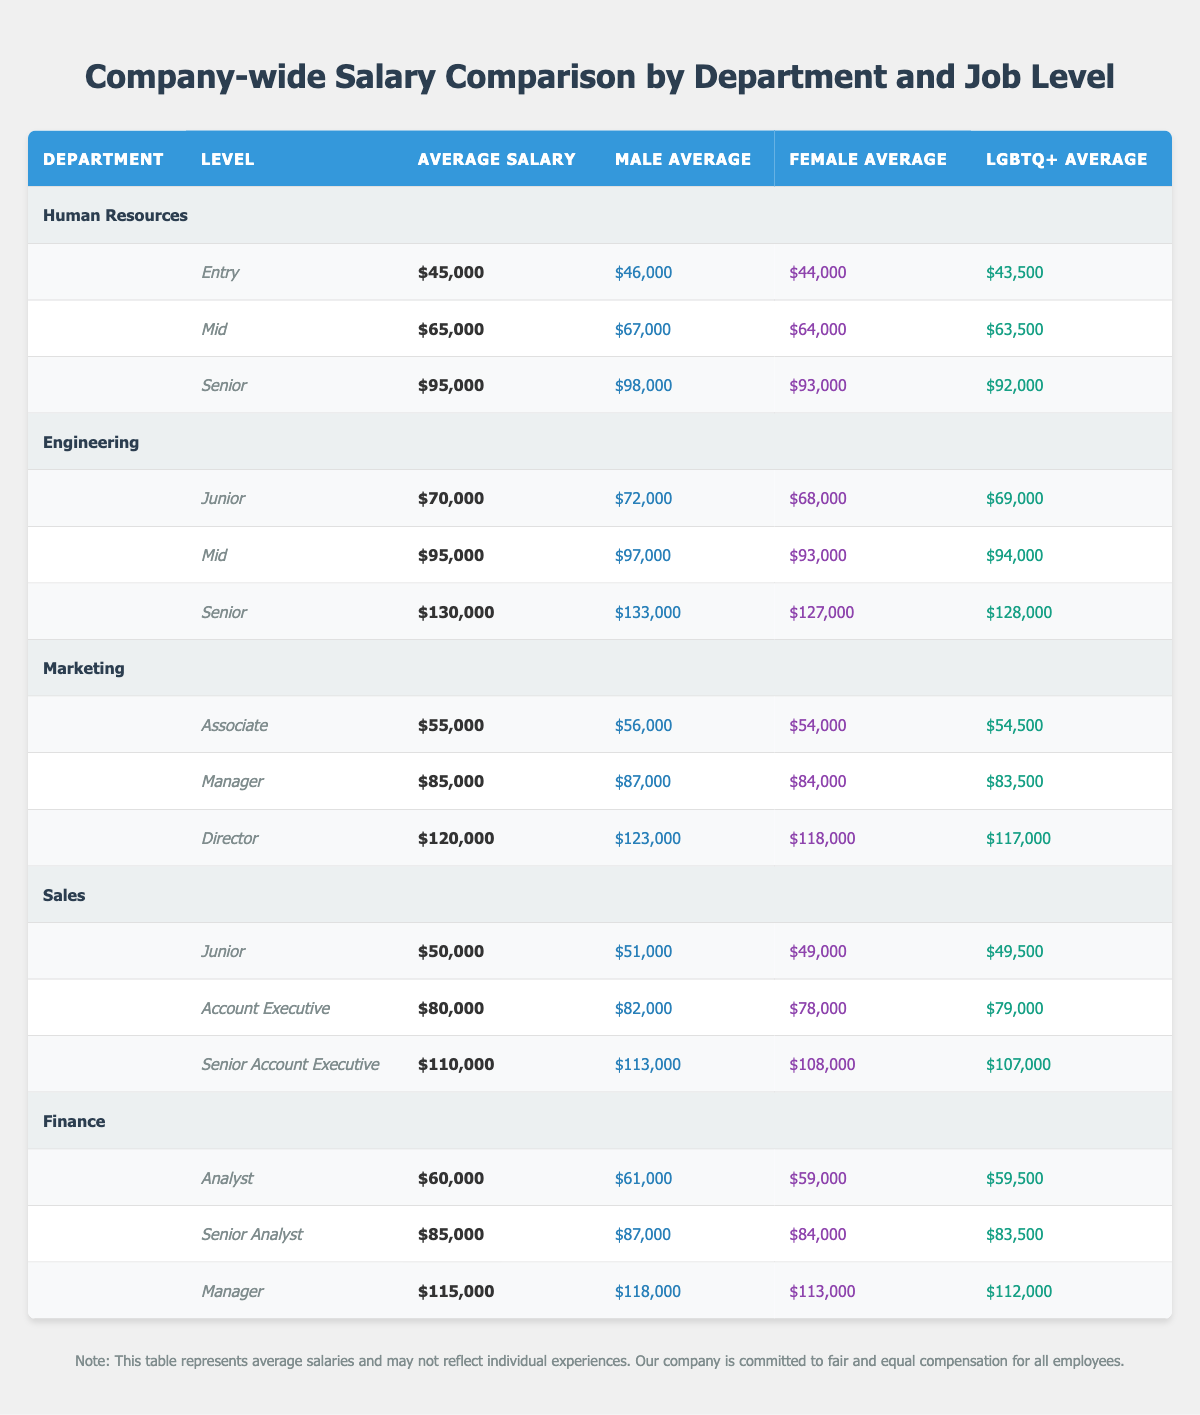What is the average salary for a Senior Analyst in the Finance department? According to the table, the average salary for a Senior Analyst is listed as $85,000.
Answer: $85,000 Which department has the highest average salary for the Senior level? Looking at the table, the Engineering department has the highest average salary for Senior level at $130,000.
Answer: Engineering Is the average salary for Junior level in Sales higher than that in Human Resources? The average salary for Junior level in Sales is $50,000, while in Human Resources it is $45,000. Since $50,000 is greater than $45,000, the statement is true.
Answer: Yes What is the difference in average salary between the male and LGBTQ+ averages for the Mid level in Human Resources? The male average salary for Mid level in Human Resources is $67,000 and the LGBTQ+ average is $63,500. The difference is calculated as $67,000 - $63,500 = $3,500.
Answer: $3,500 Which job level in Marketing has the lowest average salary? The table shows that the Associate level in Marketing has the lowest average salary at $55,000 when comparing Associate, Manager, and Director levels.
Answer: Associate What is the average salary for female employees in the Engineering department at the Senior level? The table provides the average salary for female employees in the Engineering department for Senior level as $127,000.
Answer: $127,000 Is the average salary for the Manager level in Finance higher than that of the Director level in Marketing? The average salary for the Manager level in Finance is $115,000 and the average salary for the Director level in Marketing is $120,000. Since $115,000 is less than $120,000, the statement is false.
Answer: No What is the total average salary for all Junior level positions across departments? From the table, the average salaries for Junior level are: Sales $50,000, Engineering $70,000, and Human Resources $45,000. Summing these gives $50,000 + $70,000 + $45,000 = $165,000. To find the total average, divide by the number of positions (3): $165,000/3 = $55,000.
Answer: $55,000 